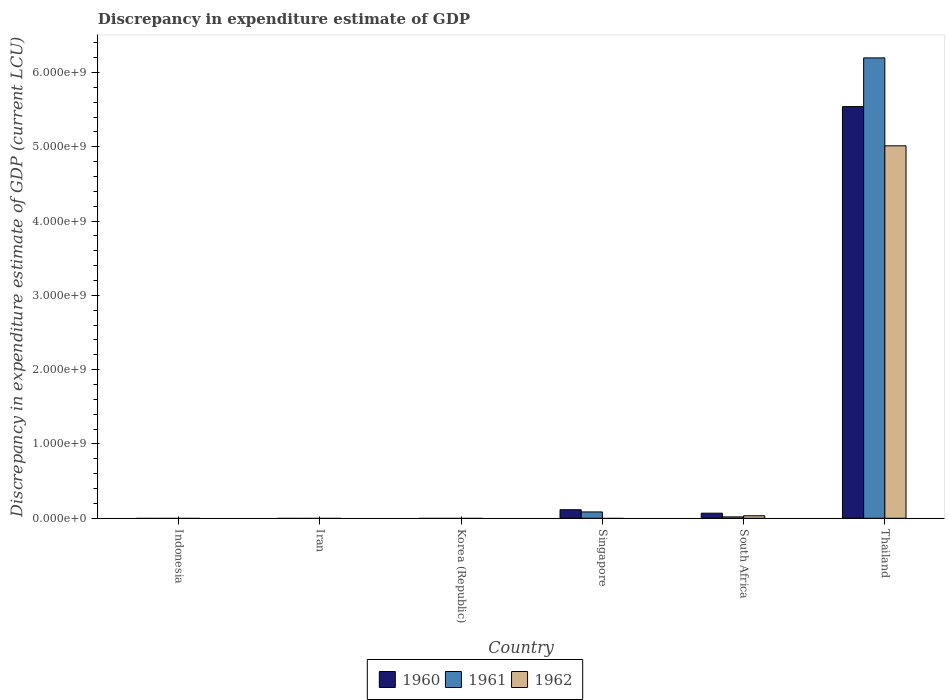How many different coloured bars are there?
Your answer should be compact. 3. Are the number of bars per tick equal to the number of legend labels?
Your answer should be compact. No. Are the number of bars on each tick of the X-axis equal?
Offer a terse response. No. How many bars are there on the 5th tick from the left?
Your answer should be very brief. 3. How many bars are there on the 6th tick from the right?
Your response must be concise. 0. What is the label of the 4th group of bars from the left?
Your answer should be compact. Singapore. In how many cases, is the number of bars for a given country not equal to the number of legend labels?
Make the answer very short. 4. Across all countries, what is the maximum discrepancy in expenditure estimate of GDP in 1961?
Ensure brevity in your answer.  6.20e+09. Across all countries, what is the minimum discrepancy in expenditure estimate of GDP in 1960?
Your answer should be compact. 0. In which country was the discrepancy in expenditure estimate of GDP in 1960 maximum?
Keep it short and to the point. Thailand. What is the total discrepancy in expenditure estimate of GDP in 1960 in the graph?
Keep it short and to the point. 5.72e+09. What is the difference between the discrepancy in expenditure estimate of GDP in 1961 in Singapore and that in South Africa?
Make the answer very short. 6.69e+07. What is the difference between the discrepancy in expenditure estimate of GDP in 1962 in South Africa and the discrepancy in expenditure estimate of GDP in 1961 in Iran?
Your response must be concise. 3.40e+07. What is the average discrepancy in expenditure estimate of GDP in 1962 per country?
Your answer should be compact. 8.41e+08. What is the difference between the discrepancy in expenditure estimate of GDP of/in 1961 and discrepancy in expenditure estimate of GDP of/in 1962 in Thailand?
Provide a short and direct response. 1.18e+09. In how many countries, is the discrepancy in expenditure estimate of GDP in 1962 greater than 200000000 LCU?
Offer a terse response. 1. Is the discrepancy in expenditure estimate of GDP in 1960 in Singapore less than that in South Africa?
Offer a terse response. No. What is the difference between the highest and the second highest discrepancy in expenditure estimate of GDP in 1961?
Your answer should be compact. 6.11e+09. What is the difference between the highest and the lowest discrepancy in expenditure estimate of GDP in 1960?
Your response must be concise. 5.54e+09. Is the sum of the discrepancy in expenditure estimate of GDP in 1960 in South Africa and Thailand greater than the maximum discrepancy in expenditure estimate of GDP in 1962 across all countries?
Provide a succinct answer. Yes. Is it the case that in every country, the sum of the discrepancy in expenditure estimate of GDP in 1960 and discrepancy in expenditure estimate of GDP in 1961 is greater than the discrepancy in expenditure estimate of GDP in 1962?
Keep it short and to the point. No. How many countries are there in the graph?
Keep it short and to the point. 6. What is the difference between two consecutive major ticks on the Y-axis?
Make the answer very short. 1.00e+09. Are the values on the major ticks of Y-axis written in scientific E-notation?
Ensure brevity in your answer.  Yes. Does the graph contain any zero values?
Provide a succinct answer. Yes. Does the graph contain grids?
Offer a terse response. No. Where does the legend appear in the graph?
Offer a very short reply. Bottom center. How many legend labels are there?
Ensure brevity in your answer.  3. What is the title of the graph?
Your response must be concise. Discrepancy in expenditure estimate of GDP. Does "2012" appear as one of the legend labels in the graph?
Provide a succinct answer. No. What is the label or title of the Y-axis?
Offer a terse response. Discrepancy in expenditure estimate of GDP (current LCU). What is the Discrepancy in expenditure estimate of GDP (current LCU) of 1961 in Indonesia?
Offer a very short reply. 0. What is the Discrepancy in expenditure estimate of GDP (current LCU) in 1960 in Iran?
Make the answer very short. 0. What is the Discrepancy in expenditure estimate of GDP (current LCU) of 1961 in Iran?
Offer a very short reply. 0. What is the Discrepancy in expenditure estimate of GDP (current LCU) of 1962 in Iran?
Offer a very short reply. 0. What is the Discrepancy in expenditure estimate of GDP (current LCU) of 1960 in Korea (Republic)?
Provide a short and direct response. 0. What is the Discrepancy in expenditure estimate of GDP (current LCU) of 1961 in Korea (Republic)?
Provide a short and direct response. 0. What is the Discrepancy in expenditure estimate of GDP (current LCU) of 1960 in Singapore?
Provide a succinct answer. 1.15e+08. What is the Discrepancy in expenditure estimate of GDP (current LCU) in 1961 in Singapore?
Provide a succinct answer. 8.53e+07. What is the Discrepancy in expenditure estimate of GDP (current LCU) of 1962 in Singapore?
Your response must be concise. 0. What is the Discrepancy in expenditure estimate of GDP (current LCU) in 1960 in South Africa?
Keep it short and to the point. 6.83e+07. What is the Discrepancy in expenditure estimate of GDP (current LCU) of 1961 in South Africa?
Make the answer very short. 1.84e+07. What is the Discrepancy in expenditure estimate of GDP (current LCU) in 1962 in South Africa?
Ensure brevity in your answer.  3.40e+07. What is the Discrepancy in expenditure estimate of GDP (current LCU) of 1960 in Thailand?
Make the answer very short. 5.54e+09. What is the Discrepancy in expenditure estimate of GDP (current LCU) of 1961 in Thailand?
Provide a succinct answer. 6.20e+09. What is the Discrepancy in expenditure estimate of GDP (current LCU) in 1962 in Thailand?
Keep it short and to the point. 5.01e+09. Across all countries, what is the maximum Discrepancy in expenditure estimate of GDP (current LCU) of 1960?
Your response must be concise. 5.54e+09. Across all countries, what is the maximum Discrepancy in expenditure estimate of GDP (current LCU) in 1961?
Keep it short and to the point. 6.20e+09. Across all countries, what is the maximum Discrepancy in expenditure estimate of GDP (current LCU) in 1962?
Give a very brief answer. 5.01e+09. Across all countries, what is the minimum Discrepancy in expenditure estimate of GDP (current LCU) in 1960?
Give a very brief answer. 0. Across all countries, what is the minimum Discrepancy in expenditure estimate of GDP (current LCU) in 1961?
Keep it short and to the point. 0. Across all countries, what is the minimum Discrepancy in expenditure estimate of GDP (current LCU) in 1962?
Give a very brief answer. 0. What is the total Discrepancy in expenditure estimate of GDP (current LCU) in 1960 in the graph?
Ensure brevity in your answer.  5.72e+09. What is the total Discrepancy in expenditure estimate of GDP (current LCU) of 1961 in the graph?
Ensure brevity in your answer.  6.30e+09. What is the total Discrepancy in expenditure estimate of GDP (current LCU) in 1962 in the graph?
Your response must be concise. 5.05e+09. What is the difference between the Discrepancy in expenditure estimate of GDP (current LCU) of 1960 in Singapore and that in South Africa?
Keep it short and to the point. 4.66e+07. What is the difference between the Discrepancy in expenditure estimate of GDP (current LCU) of 1961 in Singapore and that in South Africa?
Provide a succinct answer. 6.69e+07. What is the difference between the Discrepancy in expenditure estimate of GDP (current LCU) in 1960 in Singapore and that in Thailand?
Give a very brief answer. -5.43e+09. What is the difference between the Discrepancy in expenditure estimate of GDP (current LCU) in 1961 in Singapore and that in Thailand?
Provide a short and direct response. -6.11e+09. What is the difference between the Discrepancy in expenditure estimate of GDP (current LCU) of 1960 in South Africa and that in Thailand?
Your answer should be very brief. -5.47e+09. What is the difference between the Discrepancy in expenditure estimate of GDP (current LCU) of 1961 in South Africa and that in Thailand?
Keep it short and to the point. -6.18e+09. What is the difference between the Discrepancy in expenditure estimate of GDP (current LCU) in 1962 in South Africa and that in Thailand?
Make the answer very short. -4.98e+09. What is the difference between the Discrepancy in expenditure estimate of GDP (current LCU) of 1960 in Singapore and the Discrepancy in expenditure estimate of GDP (current LCU) of 1961 in South Africa?
Offer a terse response. 9.65e+07. What is the difference between the Discrepancy in expenditure estimate of GDP (current LCU) of 1960 in Singapore and the Discrepancy in expenditure estimate of GDP (current LCU) of 1962 in South Africa?
Make the answer very short. 8.09e+07. What is the difference between the Discrepancy in expenditure estimate of GDP (current LCU) of 1961 in Singapore and the Discrepancy in expenditure estimate of GDP (current LCU) of 1962 in South Africa?
Ensure brevity in your answer.  5.13e+07. What is the difference between the Discrepancy in expenditure estimate of GDP (current LCU) of 1960 in Singapore and the Discrepancy in expenditure estimate of GDP (current LCU) of 1961 in Thailand?
Offer a very short reply. -6.08e+09. What is the difference between the Discrepancy in expenditure estimate of GDP (current LCU) in 1960 in Singapore and the Discrepancy in expenditure estimate of GDP (current LCU) in 1962 in Thailand?
Ensure brevity in your answer.  -4.90e+09. What is the difference between the Discrepancy in expenditure estimate of GDP (current LCU) in 1961 in Singapore and the Discrepancy in expenditure estimate of GDP (current LCU) in 1962 in Thailand?
Ensure brevity in your answer.  -4.93e+09. What is the difference between the Discrepancy in expenditure estimate of GDP (current LCU) of 1960 in South Africa and the Discrepancy in expenditure estimate of GDP (current LCU) of 1961 in Thailand?
Offer a very short reply. -6.13e+09. What is the difference between the Discrepancy in expenditure estimate of GDP (current LCU) in 1960 in South Africa and the Discrepancy in expenditure estimate of GDP (current LCU) in 1962 in Thailand?
Offer a terse response. -4.95e+09. What is the difference between the Discrepancy in expenditure estimate of GDP (current LCU) of 1961 in South Africa and the Discrepancy in expenditure estimate of GDP (current LCU) of 1962 in Thailand?
Give a very brief answer. -5.00e+09. What is the average Discrepancy in expenditure estimate of GDP (current LCU) of 1960 per country?
Your response must be concise. 9.54e+08. What is the average Discrepancy in expenditure estimate of GDP (current LCU) of 1961 per country?
Your response must be concise. 1.05e+09. What is the average Discrepancy in expenditure estimate of GDP (current LCU) in 1962 per country?
Make the answer very short. 8.41e+08. What is the difference between the Discrepancy in expenditure estimate of GDP (current LCU) of 1960 and Discrepancy in expenditure estimate of GDP (current LCU) of 1961 in Singapore?
Ensure brevity in your answer.  2.96e+07. What is the difference between the Discrepancy in expenditure estimate of GDP (current LCU) in 1960 and Discrepancy in expenditure estimate of GDP (current LCU) in 1961 in South Africa?
Ensure brevity in your answer.  4.99e+07. What is the difference between the Discrepancy in expenditure estimate of GDP (current LCU) in 1960 and Discrepancy in expenditure estimate of GDP (current LCU) in 1962 in South Africa?
Keep it short and to the point. 3.43e+07. What is the difference between the Discrepancy in expenditure estimate of GDP (current LCU) of 1961 and Discrepancy in expenditure estimate of GDP (current LCU) of 1962 in South Africa?
Offer a very short reply. -1.56e+07. What is the difference between the Discrepancy in expenditure estimate of GDP (current LCU) in 1960 and Discrepancy in expenditure estimate of GDP (current LCU) in 1961 in Thailand?
Provide a short and direct response. -6.56e+08. What is the difference between the Discrepancy in expenditure estimate of GDP (current LCU) of 1960 and Discrepancy in expenditure estimate of GDP (current LCU) of 1962 in Thailand?
Offer a terse response. 5.28e+08. What is the difference between the Discrepancy in expenditure estimate of GDP (current LCU) in 1961 and Discrepancy in expenditure estimate of GDP (current LCU) in 1962 in Thailand?
Provide a short and direct response. 1.18e+09. What is the ratio of the Discrepancy in expenditure estimate of GDP (current LCU) in 1960 in Singapore to that in South Africa?
Your answer should be very brief. 1.68. What is the ratio of the Discrepancy in expenditure estimate of GDP (current LCU) of 1961 in Singapore to that in South Africa?
Make the answer very short. 4.64. What is the ratio of the Discrepancy in expenditure estimate of GDP (current LCU) of 1960 in Singapore to that in Thailand?
Keep it short and to the point. 0.02. What is the ratio of the Discrepancy in expenditure estimate of GDP (current LCU) in 1961 in Singapore to that in Thailand?
Your answer should be compact. 0.01. What is the ratio of the Discrepancy in expenditure estimate of GDP (current LCU) in 1960 in South Africa to that in Thailand?
Provide a succinct answer. 0.01. What is the ratio of the Discrepancy in expenditure estimate of GDP (current LCU) in 1961 in South Africa to that in Thailand?
Your response must be concise. 0. What is the ratio of the Discrepancy in expenditure estimate of GDP (current LCU) of 1962 in South Africa to that in Thailand?
Your response must be concise. 0.01. What is the difference between the highest and the second highest Discrepancy in expenditure estimate of GDP (current LCU) in 1960?
Provide a short and direct response. 5.43e+09. What is the difference between the highest and the second highest Discrepancy in expenditure estimate of GDP (current LCU) in 1961?
Offer a very short reply. 6.11e+09. What is the difference between the highest and the lowest Discrepancy in expenditure estimate of GDP (current LCU) of 1960?
Provide a short and direct response. 5.54e+09. What is the difference between the highest and the lowest Discrepancy in expenditure estimate of GDP (current LCU) in 1961?
Your response must be concise. 6.20e+09. What is the difference between the highest and the lowest Discrepancy in expenditure estimate of GDP (current LCU) in 1962?
Make the answer very short. 5.01e+09. 